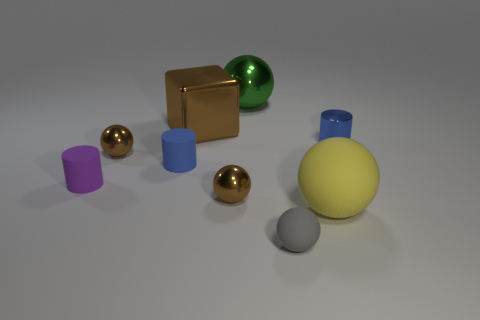Subtract 2 spheres. How many spheres are left? 3 Subtract all blue spheres. Subtract all red cylinders. How many spheres are left? 5 Subtract all spheres. How many objects are left? 4 Subtract 0 green cubes. How many objects are left? 9 Subtract all blue matte cylinders. Subtract all gray matte spheres. How many objects are left? 7 Add 8 metal cubes. How many metal cubes are left? 9 Add 3 tiny green balls. How many tiny green balls exist? 3 